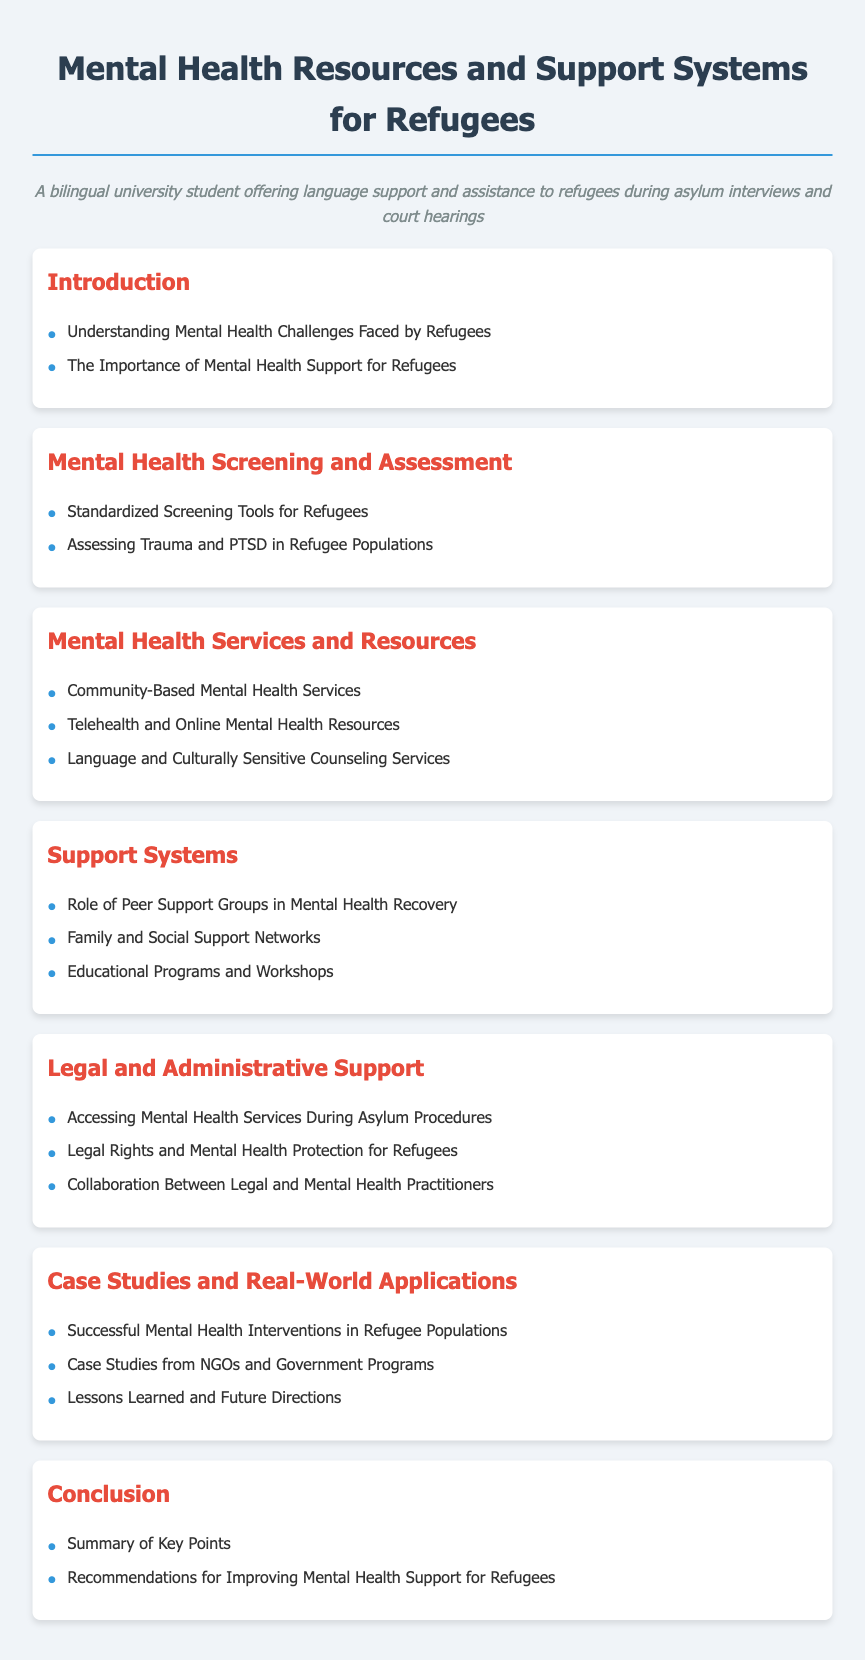What is the title of the document? The title is located at the top of the document, indicating its primary subject matter.
Answer: Mental Health Resources and Support Systems for Refugees What section discusses trauma and PTSD? This section involves specific mental health challenges related to trauma, which appears under a relevant heading.
Answer: Mental Health Screening and Assessment How many main sections are there in the document? By counting the distinct sections outlined in the table of contents, we determine the number of main areas.
Answer: Six What resource type is mentioned for accessing mental health services? This identifies a specific type of resource that is suggested for improving access to mental health care.
Answer: Telehealth and Online Mental Health Resources What role do peer support groups play? This assesses the function of specific support structures mentioned in relation to mental health recovery.
Answer: Mental Health Recovery What is summarized in the conclusion section? The conclusion section provides a recap of the document's critical takeaways, highlighting overall themes.
Answer: Key Points 